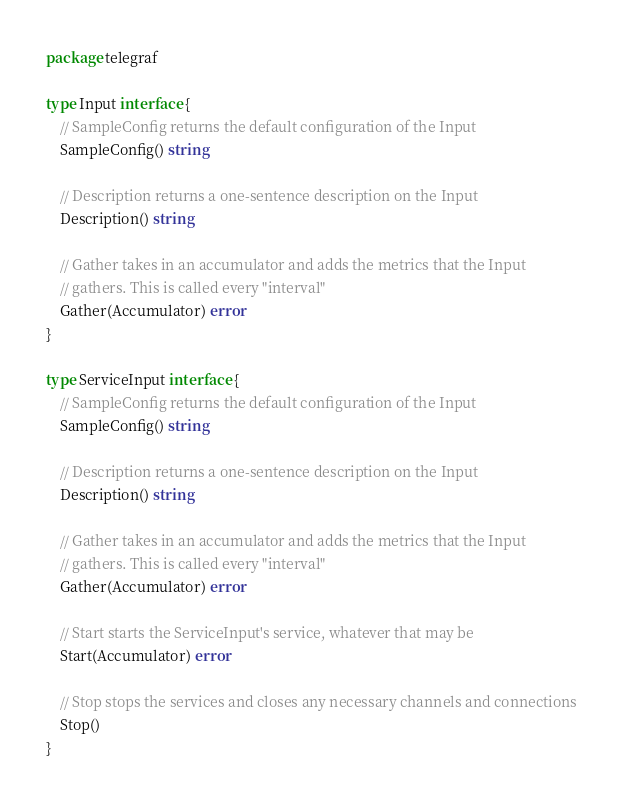<code> <loc_0><loc_0><loc_500><loc_500><_Go_>package telegraf

type Input interface {
	// SampleConfig returns the default configuration of the Input
	SampleConfig() string

	// Description returns a one-sentence description on the Input
	Description() string

	// Gather takes in an accumulator and adds the metrics that the Input
	// gathers. This is called every "interval"
	Gather(Accumulator) error
}

type ServiceInput interface {
	// SampleConfig returns the default configuration of the Input
	SampleConfig() string

	// Description returns a one-sentence description on the Input
	Description() string

	// Gather takes in an accumulator and adds the metrics that the Input
	// gathers. This is called every "interval"
	Gather(Accumulator) error

	// Start starts the ServiceInput's service, whatever that may be
	Start(Accumulator) error

	// Stop stops the services and closes any necessary channels and connections
	Stop()
}
</code> 